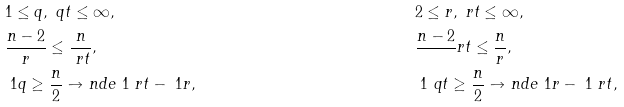<formula> <loc_0><loc_0><loc_500><loc_500>& 1 \leq q , \ q t \leq \infty , & & 2 \leq r , \ r t \leq \infty , \\ & \frac { n - 2 } r \leq \frac { n } { \ r t } , & & \frac { n - 2 } \ r t \leq \frac { n } { r } , \\ & \ 1 q \geq \frac { n } { 2 } \to n d e { \ 1 \ r t - \ 1 r } , & & \ 1 \ q t \geq \frac { n } { 2 } \to n d e { \ 1 r - \ 1 \ r t } ,</formula> 